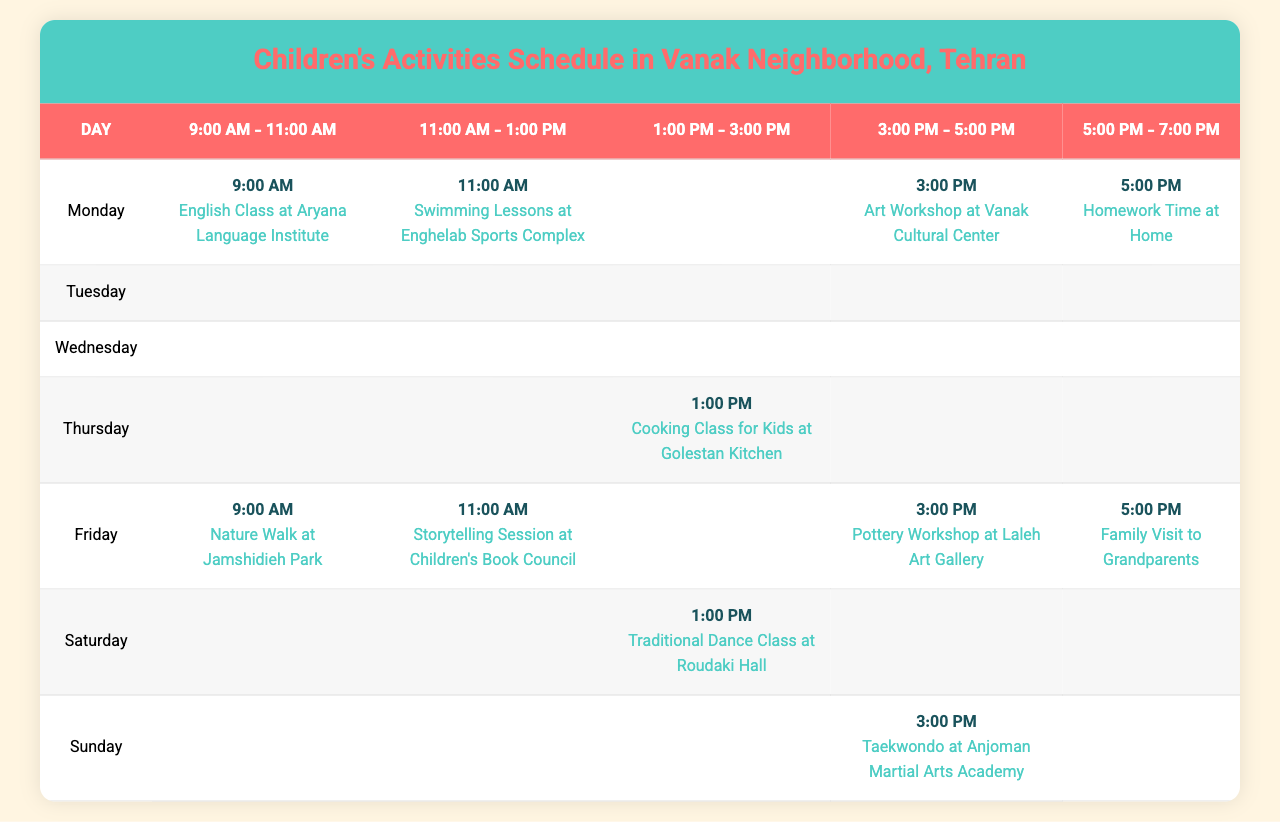What activities are scheduled for Monday at 11:00 AM? Referring to the table, on Monday at 11:00 AM, there are swimming lessons at Enghelab Sports Complex.
Answer: Swimming Lessons at Enghelab Sports Complex Which day has the highest number of scheduled activities? By counting the activities for each day, all days have 4 scheduled activities, except for Friday, which has 4 as well. Thus, all days of the week are equal in terms of activities.
Answer: All days are equal (4 activities each) What is the activity scheduled for Friday at 3:00 PM? According to the table, on Friday at 3:00 PM, there is a pottery workshop at Laleh Art Gallery.
Answer: Pottery Workshop at Laleh Art Gallery Is there a family dinner scheduled on Tuesday? The table indicates that there is a family dinner scheduled on Tuesday at 6:00 PM.
Answer: Yes How many activities occur during the mornings (before 12:00 PM) on Sunday? Looking at Sunday, there are two activities scheduled before 12:00 PM: a painting class at 9:30 AM and a robotics workshop at 11:30 AM. Therefore, the total is 2 morning activities.
Answer: 2 activities What is the most common type of activity during the week? Review of the activities shows that classes (like English, Math, Science, etc.) occur consistently across multiple days. Identifying their frequency reveals that classes are the most common type of activity.
Answer: Classes are the most common type How many times is a cooking class scheduled for the week? Upon scanning the table, a cooking class is scheduled only once during the week, specifically on Thursday at 1:00 PM.
Answer: Once Which activity occurs at 3:00 PM on Saturday? From the schedule, on Saturday at 3:00 PM, there is a basketball activity at Jordan Court.
Answer: Basketball at Jordan Court If a family wanted to participate in outdoor activities, which day would be most suitable? Evaluating the schedule for outdoor activities, Friday features a nature walk at Jamshidieh Park, and Tuesday includes playground time at Mellat Park. Thus, both days are suitable for outdoor activities.
Answer: Friday and Tuesday are suitable What is the cumulative number of activities scheduled on Thursday? On Thursday, the scheduled activities are science experiments, cooking class, gymnastics, and family movie night, which totals to 4 activities.
Answer: 4 activities 